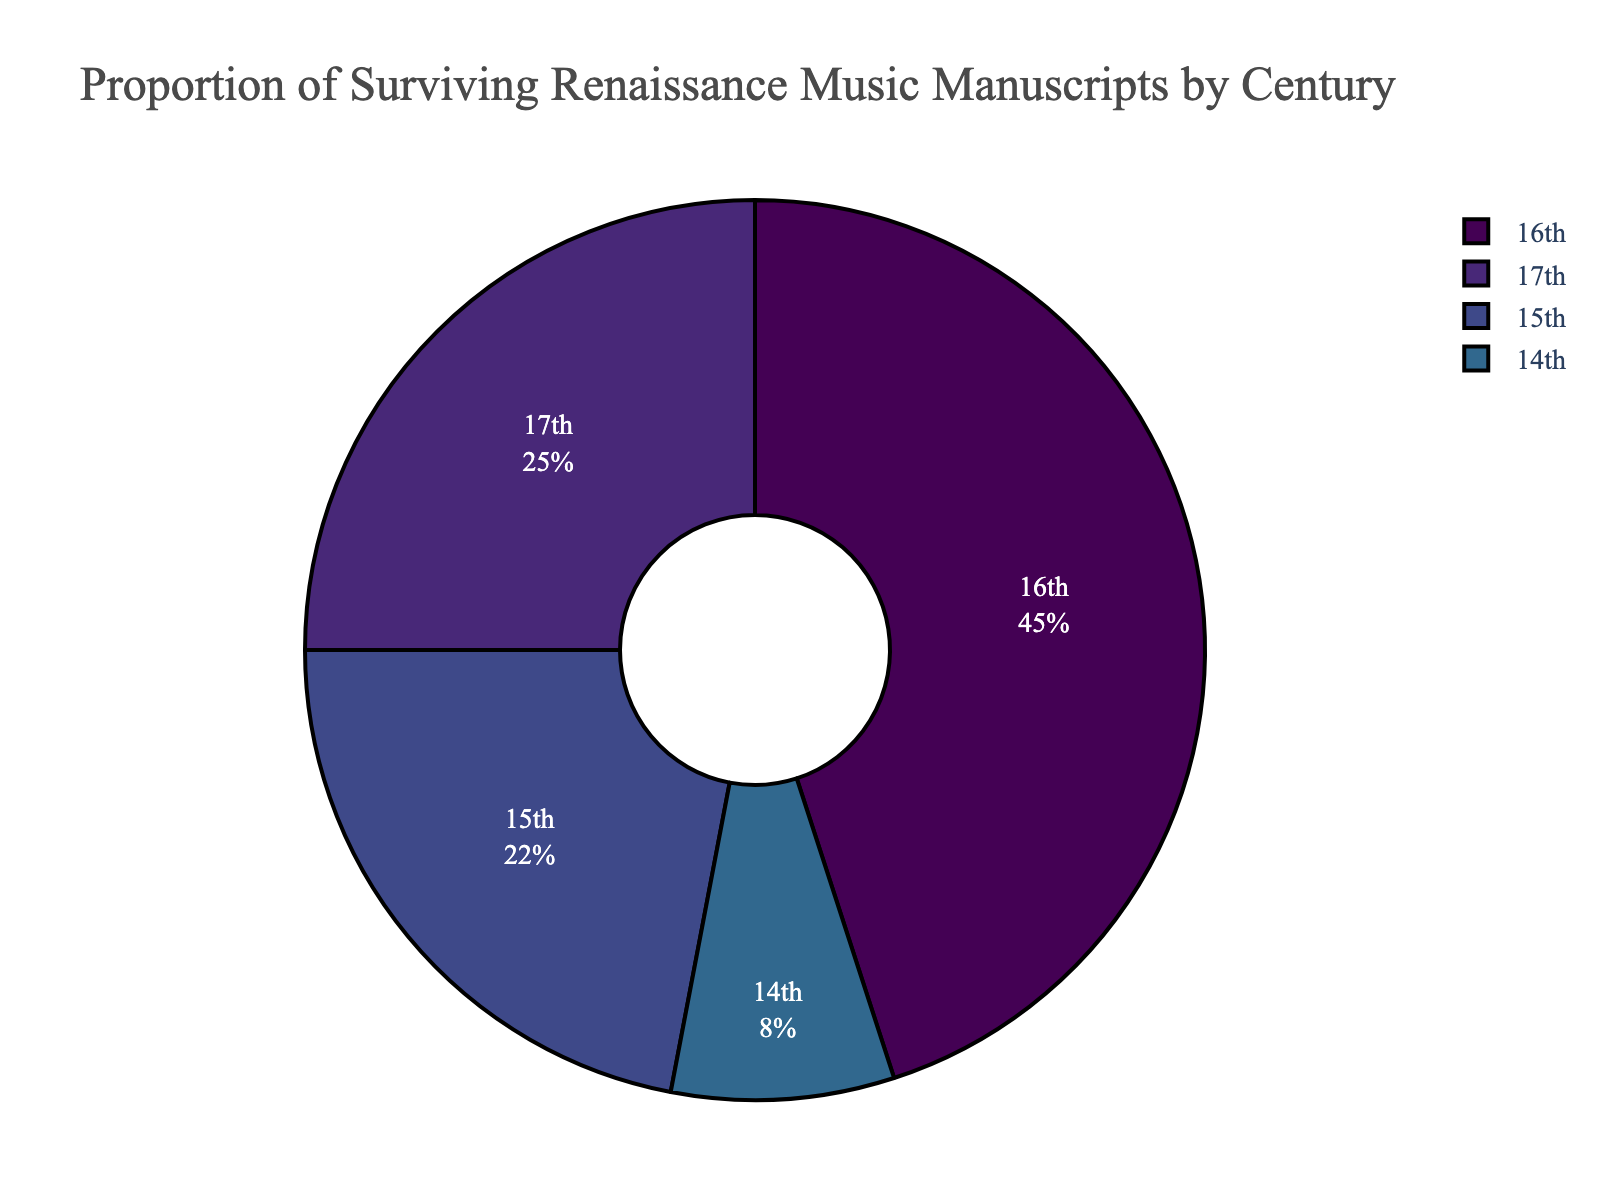What is the century with the largest proportion of surviving Renaissance music manuscripts? The figure shows that the 16th century accounts for the largest portion, indicated by the largest segment of the pie chart.
Answer: 16th century What is the combined proportion of surviving Renaissance music manuscripts from the 15th and 17th centuries? The proportion from the 15th century is 22% and from the 17th century is 25%. Adding these together gives 22% + 25% = 47%.
Answer: 47% Which century has the smallest proportion of surviving Renaissance music manuscripts? The figure shows that the 14th century has the smallest portion, indicated by the smallest segment of the pie chart.
Answer: 14th century How much larger is the proportion of surviving Renaissance music manuscripts from the 16th century compared to the 14th century? The proportion from the 16th century is 45% and from the 14th century is 8%. The difference is 45% - 8% = 37%.
Answer: 37% Which centuries together account for more than 60% of the surviving Renaissance music manuscripts? Adding the proportions of the 16th (45%) and 17th (25%) centuries gives 45% + 25% = 70%, which is more than 60%.
Answer: 16th and 17th centuries Describe the color used for the 17th century segment of the pie chart. The pie chart utilizes a Viridis color sequence. The 17th century segment is shown in a shade of green.
Answer: green Is the combined proportion of the 14th and 17th centuries greater than the proportion of the 16th century? The combined proportion of the 14th and 17th centuries is 8% + 25% = 33%, which is less than the 45% of the 16th century.
Answer: No What is the average proportion of the 14th and 15th centuries? The proportion of the 14th century is 8% and the 15th century is 22%. The average is (8% + 22%) / 2 = 30% / 2 = 15%.
Answer: 15% 